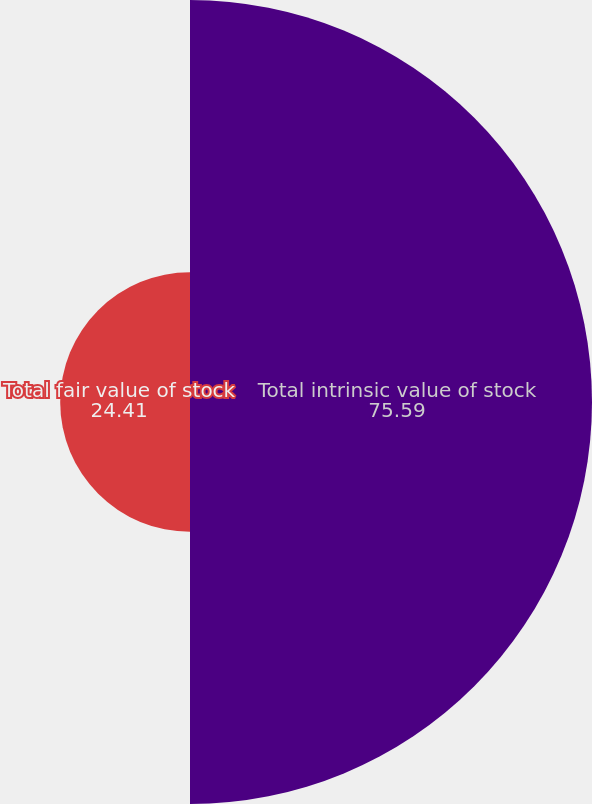<chart> <loc_0><loc_0><loc_500><loc_500><pie_chart><fcel>Total intrinsic value of stock<fcel>Total fair value of stock<nl><fcel>75.59%<fcel>24.41%<nl></chart> 